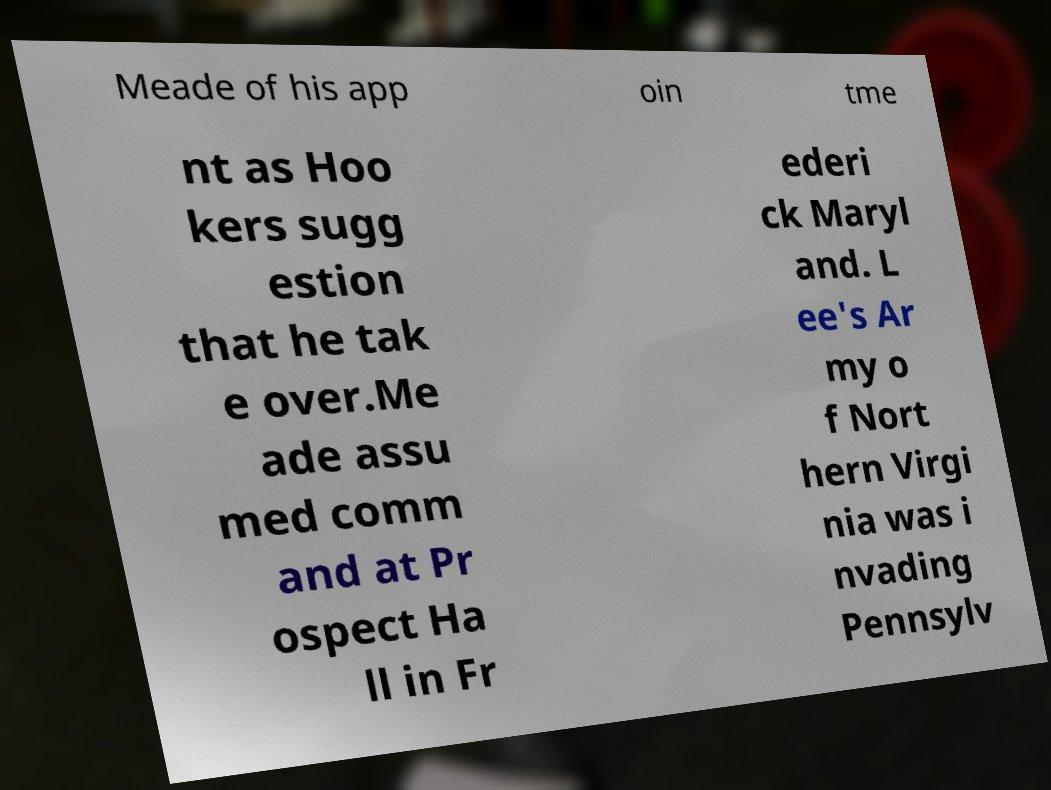I need the written content from this picture converted into text. Can you do that? Meade of his app oin tme nt as Hoo kers sugg estion that he tak e over.Me ade assu med comm and at Pr ospect Ha ll in Fr ederi ck Maryl and. L ee's Ar my o f Nort hern Virgi nia was i nvading Pennsylv 